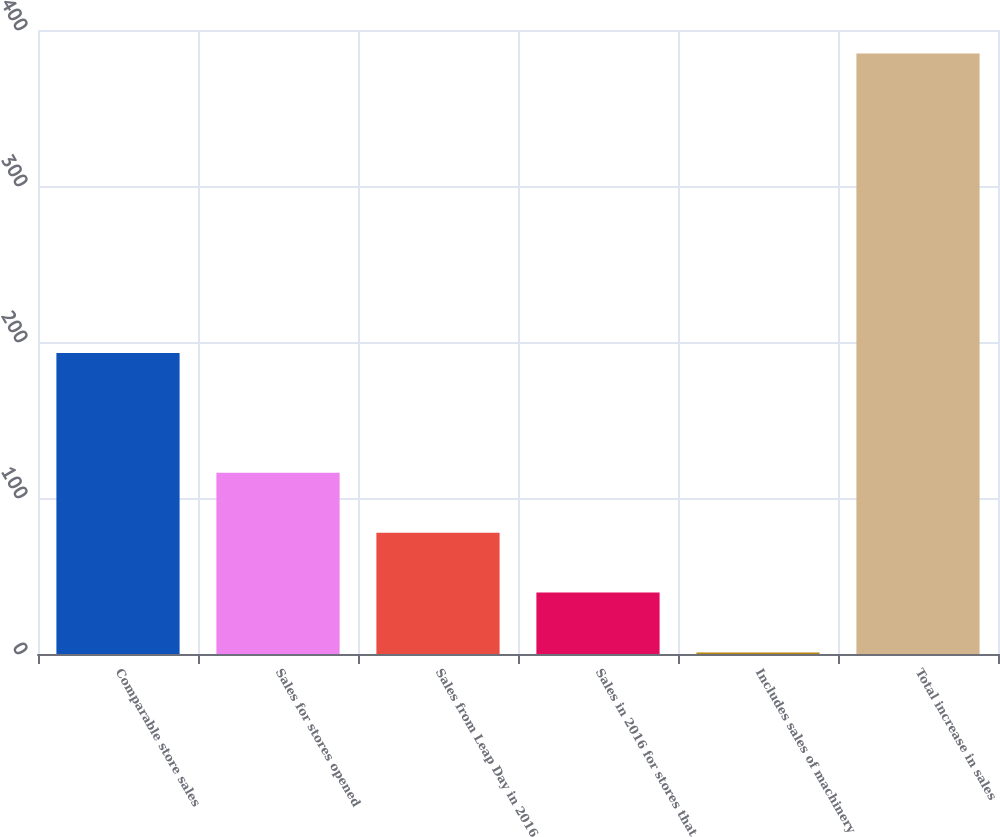Convert chart to OTSL. <chart><loc_0><loc_0><loc_500><loc_500><bar_chart><fcel>Comparable store sales<fcel>Sales for stores opened<fcel>Sales from Leap Day in 2016<fcel>Sales in 2016 for stores that<fcel>Includes sales of machinery<fcel>Total increase in sales<nl><fcel>193<fcel>116.2<fcel>77.8<fcel>39.4<fcel>1<fcel>385<nl></chart> 